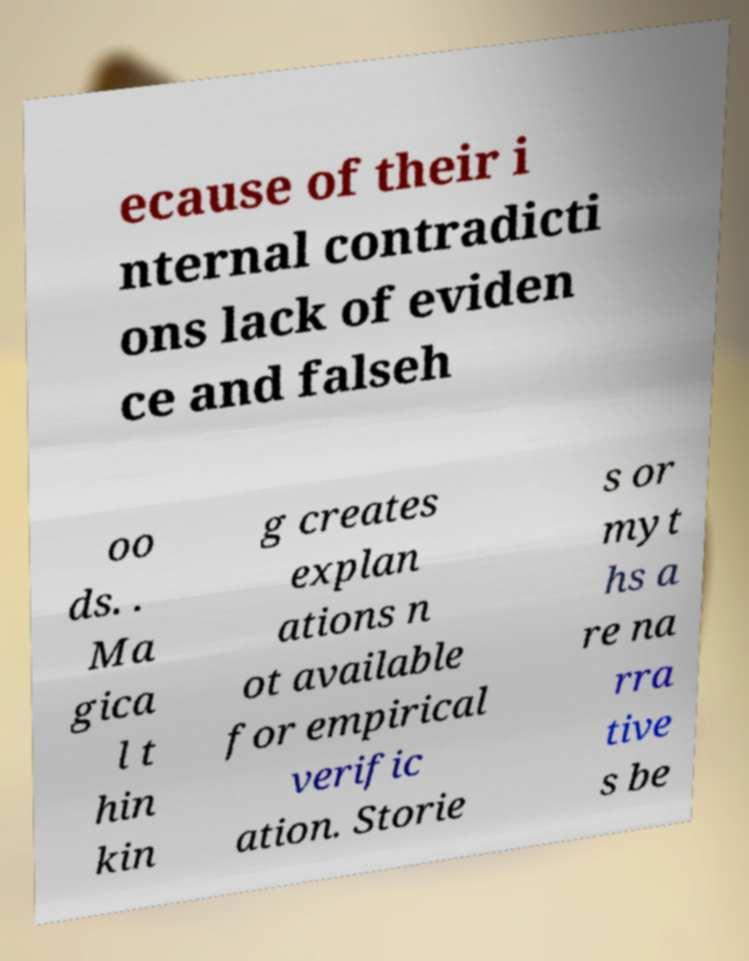Could you extract and type out the text from this image? ecause of their i nternal contradicti ons lack of eviden ce and falseh oo ds. . Ma gica l t hin kin g creates explan ations n ot available for empirical verific ation. Storie s or myt hs a re na rra tive s be 